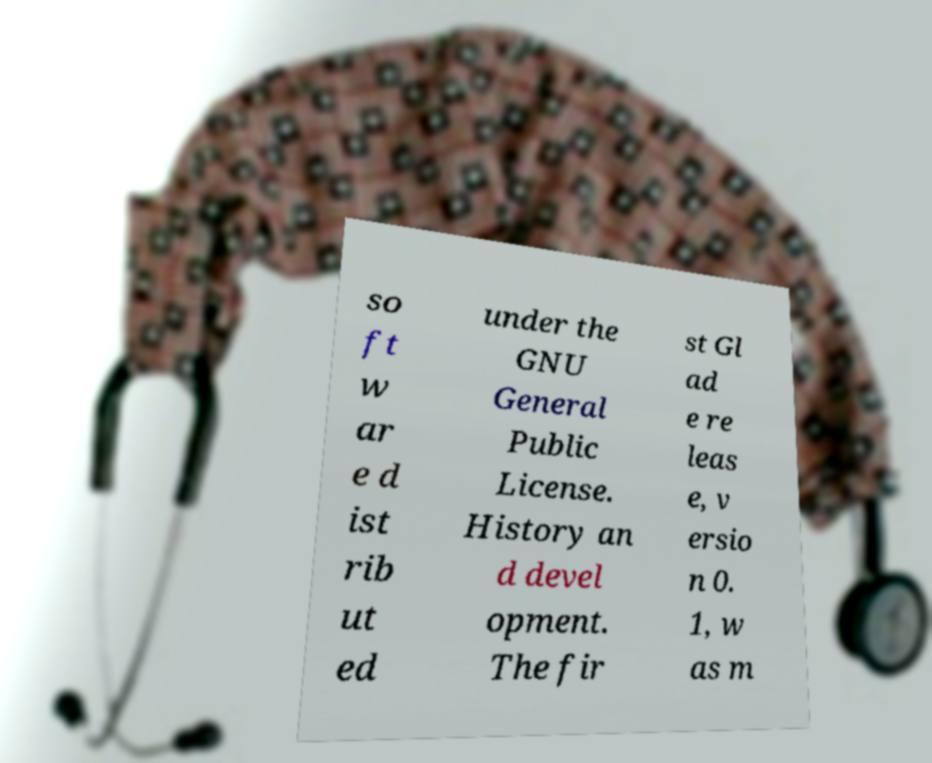Can you accurately transcribe the text from the provided image for me? so ft w ar e d ist rib ut ed under the GNU General Public License. History an d devel opment. The fir st Gl ad e re leas e, v ersio n 0. 1, w as m 